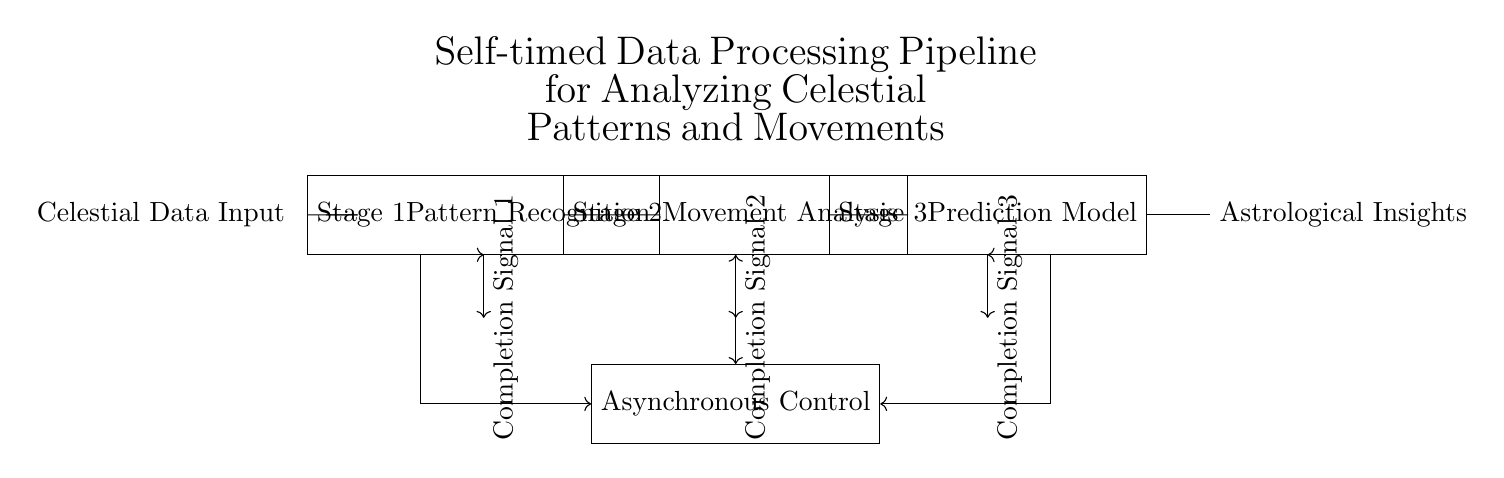What is the input to the pipeline? The input is labeled "Celestial Data Input", indicating it is the initial data provided to the processing pipeline.
Answer: Celestial Data Input How many stages are there in the pipeline? There are three distinct stages labeled: Pattern Recognition, Movement Analysis, and Prediction Model. Therefore, the total count of stages is three.
Answer: Three What type of control does the pipeline use? The control used is labeled "Asynchronous Control", distinguishing it from synchronous control by allowing stages to operate independently as they complete their processes.
Answer: Asynchronous Control What do the arrows below each stage signify? The arrows labeled "Completion Signal" indicate that each stage provides a signal once it has completed its task, allowing the subsequent stage to proceed.
Answer: Completion Signal Which stage comes last in the pipeline? The last stage is labeled "Stage 3 Prediction Model", which is the final processing phase before producing the output.
Answer: Stage 3 Prediction Model How are the stages connected? The stages are connected in series where the output of one stage feeds into the next, indicating a sequential processing flow.
Answer: In series What is the output of the pipeline? The output is labeled "Astrological Insights", representing the final product of the data processing pipeline.
Answer: Astrological Insights 